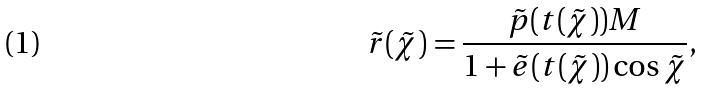Convert formula to latex. <formula><loc_0><loc_0><loc_500><loc_500>\tilde { r } ( \tilde { \chi } ) = \frac { \tilde { p } ( t ( \tilde { \chi } ) ) M } { 1 + \tilde { e } ( t ( \tilde { \chi } ) ) \cos \tilde { \chi } } ,</formula> 